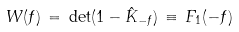<formula> <loc_0><loc_0><loc_500><loc_500>W ( f ) \, = \, \det ( 1 - \hat { K } _ { - f } ) \, \equiv \, F _ { 1 } ( - f )</formula> 